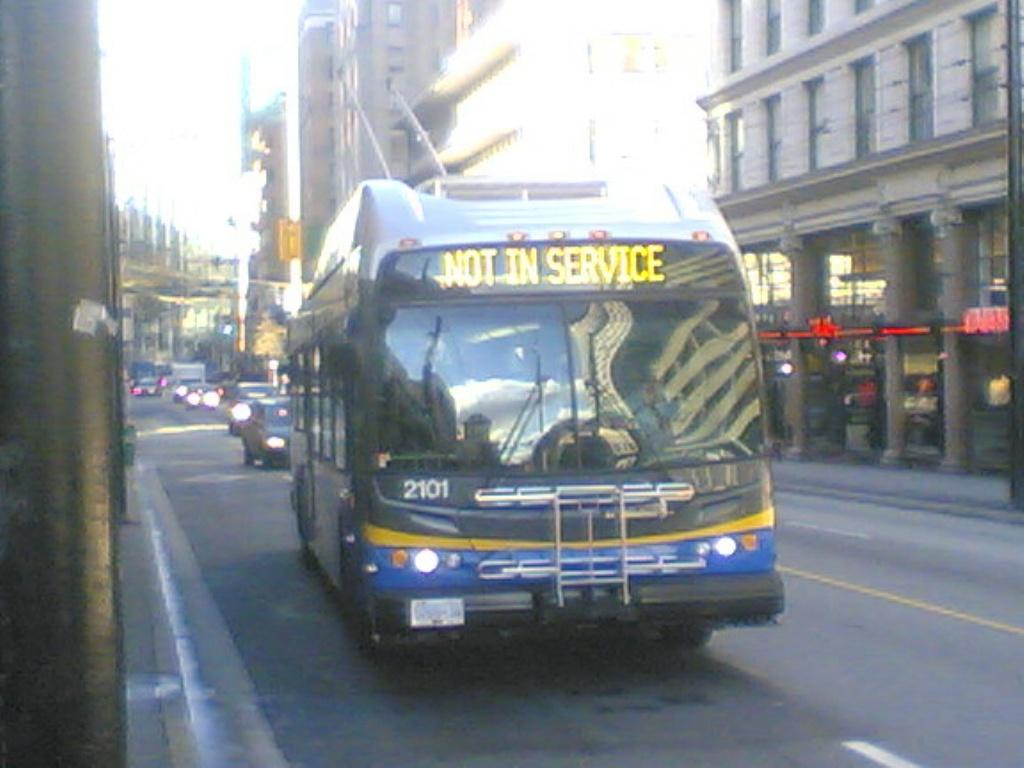What can be seen on the road in the image? There are vehicles on the road in the image. What structures are located beside the road? There are poles beside the road in the image. What type of man-made structures are present in the image? There are buildings in the image. What type of natural elements can be seen in the image? There are trees in the image. Where is the team practicing in the image? There is no team or practice visible in the image. What type of milk is being served in the image? There is no milk present in the image. 